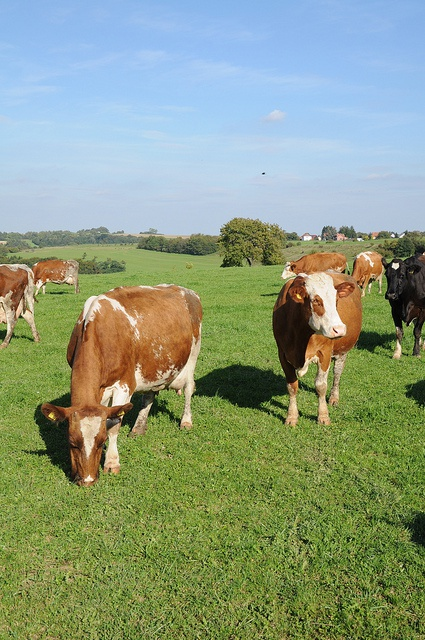Describe the objects in this image and their specific colors. I can see cow in lightblue, brown, and tan tones, cow in lightblue, black, brown, ivory, and tan tones, cow in lightblue, black, gray, and darkgreen tones, cow in lightblue, olive, gray, tan, and brown tones, and cow in lightblue, red, and tan tones in this image. 